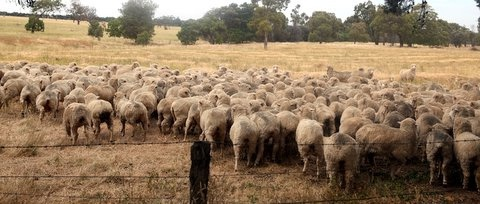Describe the objects in this image and their specific colors. I can see sheep in white, tan, gray, and black tones, sheep in white, black, gray, and maroon tones, sheep in white, black, maroon, and gray tones, sheep in white, tan, black, gray, and maroon tones, and sheep in white, gray, maroon, and black tones in this image. 